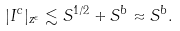<formula> <loc_0><loc_0><loc_500><loc_500>| I ^ { c } | _ { z ^ { \epsilon } } \lesssim S ^ { 1 / 2 } + S ^ { b } \approx S ^ { b } .</formula> 